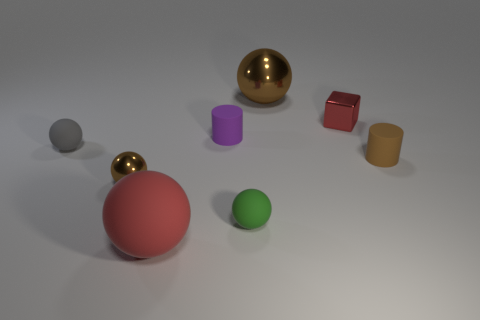Does the purple matte object have the same shape as the tiny brown object behind the tiny brown metal ball?
Your answer should be compact. Yes. There is a large matte thing that is the same color as the shiny block; what shape is it?
Offer a very short reply. Sphere. What number of big objects are behind the red thing that is in front of the brown sphere that is left of the large red matte sphere?
Give a very brief answer. 1. There is a rubber ball that is the same size as the gray thing; what is its color?
Provide a short and direct response. Green. There is a cylinder that is on the right side of the matte cylinder that is to the left of the red metal block; what is its size?
Provide a succinct answer. Small. There is a metallic object that is the same color as the tiny metal sphere; what is its size?
Give a very brief answer. Large. What number of other things are the same size as the purple cylinder?
Offer a very short reply. 5. How many small brown metallic things are there?
Your response must be concise. 1. Does the brown matte cylinder have the same size as the gray matte sphere?
Make the answer very short. Yes. What number of other objects are there of the same shape as the tiny green object?
Make the answer very short. 4. 